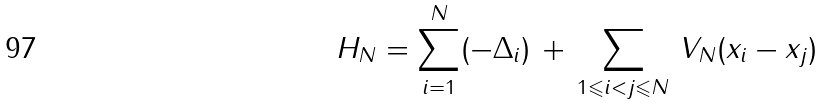Convert formula to latex. <formula><loc_0><loc_0><loc_500><loc_500>H _ { N } = \sum _ { i = 1 } ^ { N } ( - \Delta _ { i } ) \, + \, \sum _ { 1 \leqslant i < j \leqslant N } \, V _ { N } ( x _ { i } - x _ { j } )</formula> 